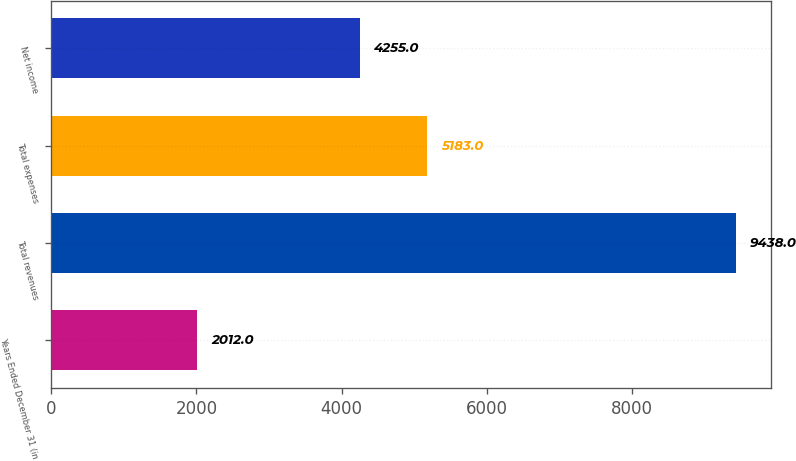Convert chart to OTSL. <chart><loc_0><loc_0><loc_500><loc_500><bar_chart><fcel>Years Ended December 31 (in<fcel>Total revenues<fcel>Total expenses<fcel>Net income<nl><fcel>2012<fcel>9438<fcel>5183<fcel>4255<nl></chart> 